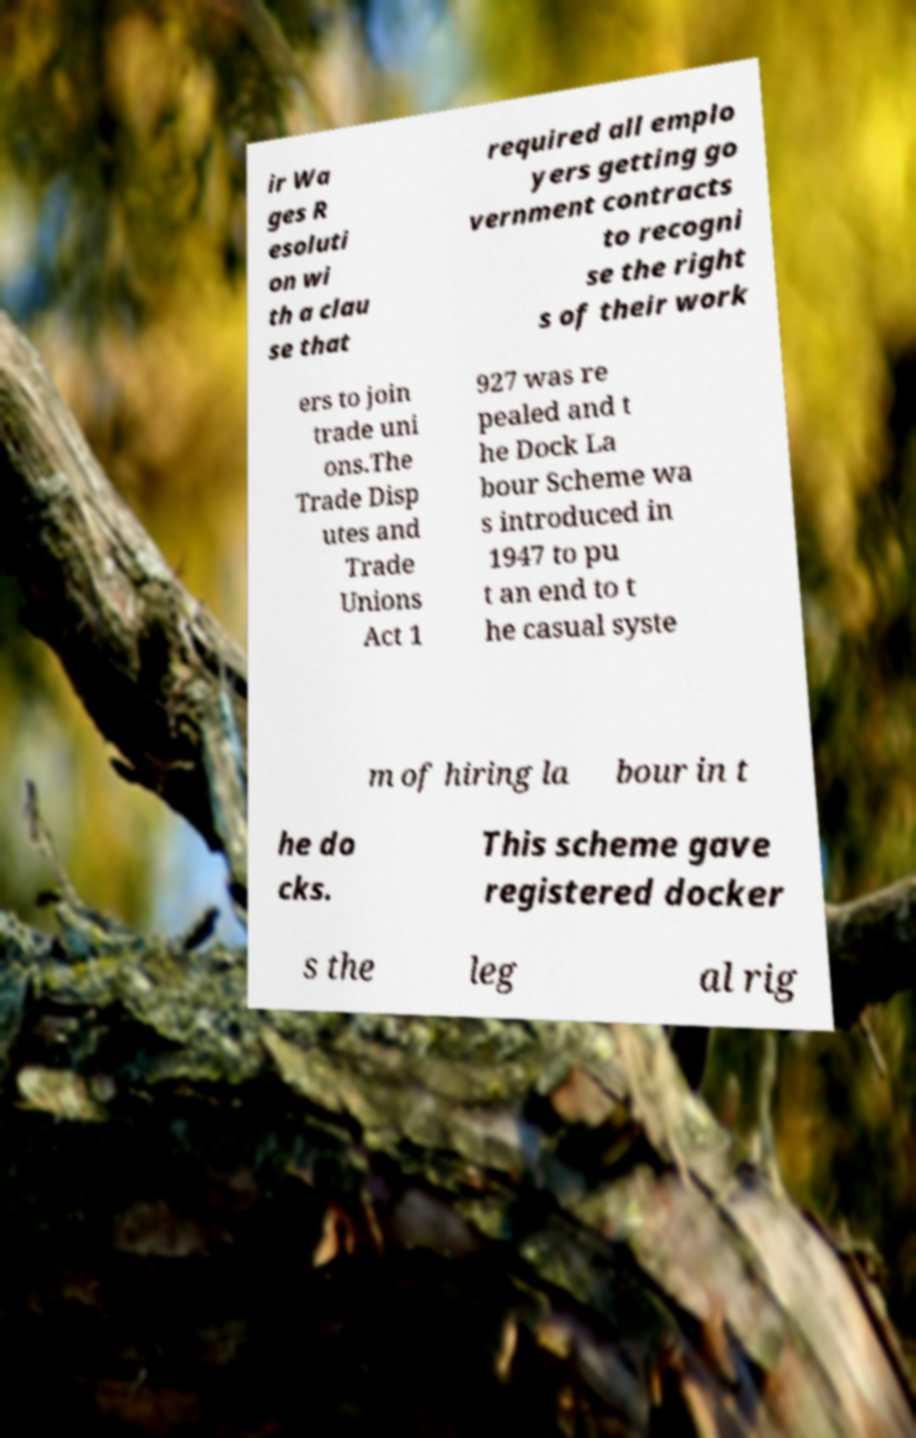What messages or text are displayed in this image? I need them in a readable, typed format. ir Wa ges R esoluti on wi th a clau se that required all emplo yers getting go vernment contracts to recogni se the right s of their work ers to join trade uni ons.The Trade Disp utes and Trade Unions Act 1 927 was re pealed and t he Dock La bour Scheme wa s introduced in 1947 to pu t an end to t he casual syste m of hiring la bour in t he do cks. This scheme gave registered docker s the leg al rig 